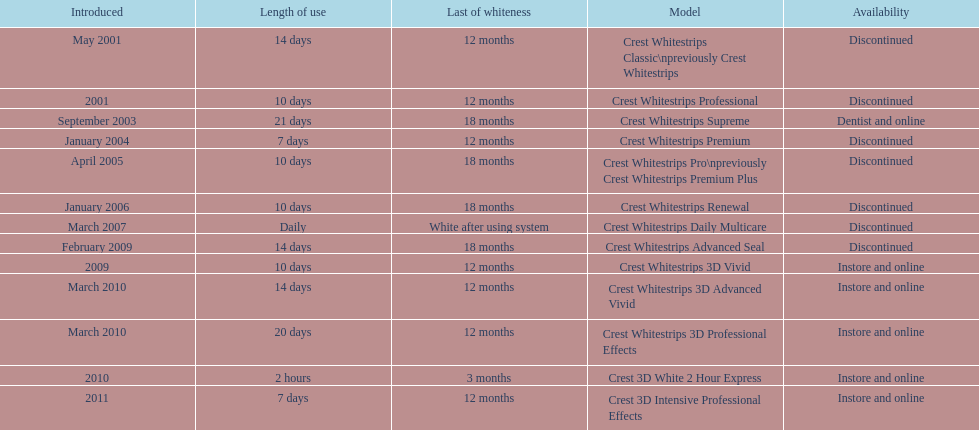Tell me the number of products that give you 12 months of whiteness. 7. 